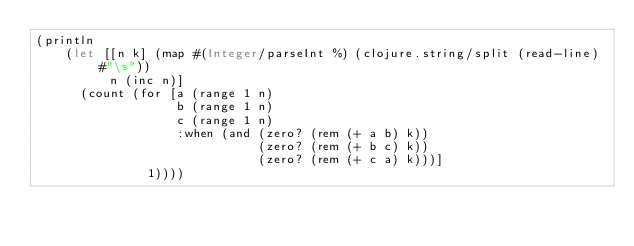Convert code to text. <code><loc_0><loc_0><loc_500><loc_500><_Clojure_>(println
    (let [[n k] (map #(Integer/parseInt %) (clojure.string/split (read-line) #"\s"))
          n (inc n)]
      (count (for [a (range 1 n)
                   b (range 1 n)
                   c (range 1 n)
                   :when (and (zero? (rem (+ a b) k))
                              (zero? (rem (+ b c) k))
                              (zero? (rem (+ c a) k)))]
               1))))</code> 